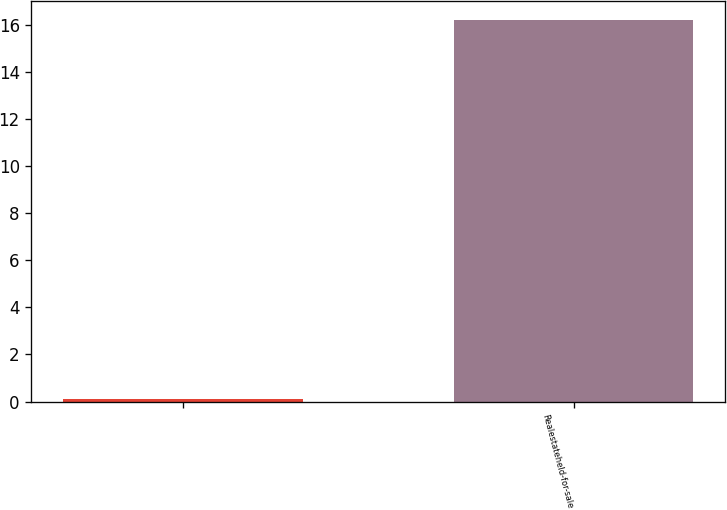Convert chart to OTSL. <chart><loc_0><loc_0><loc_500><loc_500><bar_chart><ecel><fcel>Realestateheld-for-sale<nl><fcel>0.1<fcel>16.2<nl></chart> 